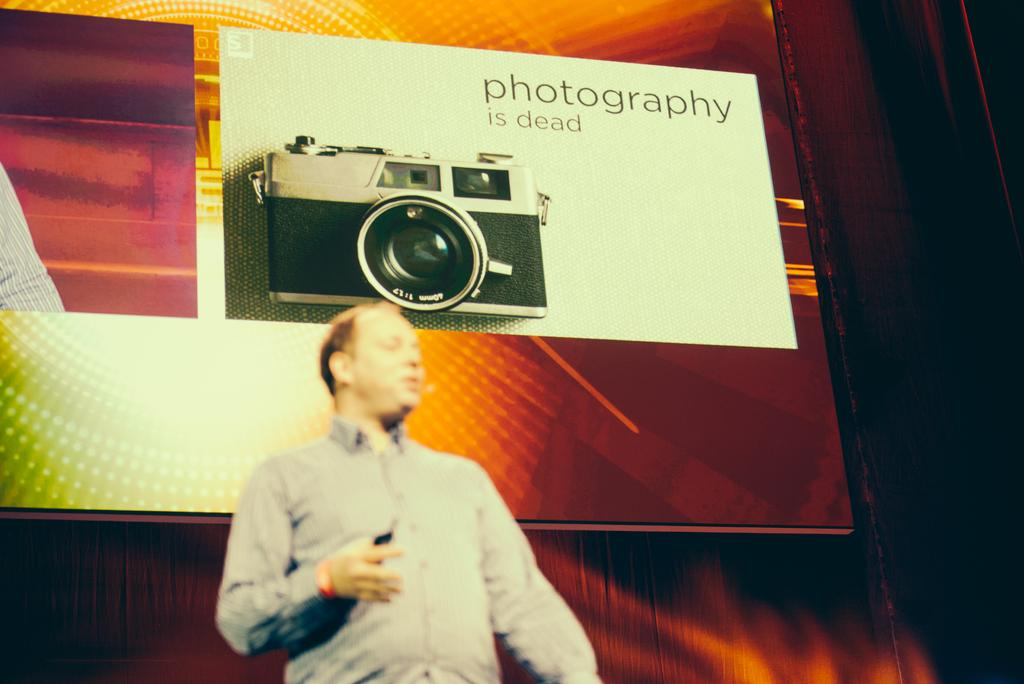Who is in the image? There is a man in the image. What can be seen in the background of the image? There is a screen in the background of the image. What is displayed on the screen? A camera is visible on the screen, and there is also text present. What type of scent can be detected from the man in the image? There is no information about the scent of the man in the image, so it cannot be determined. 